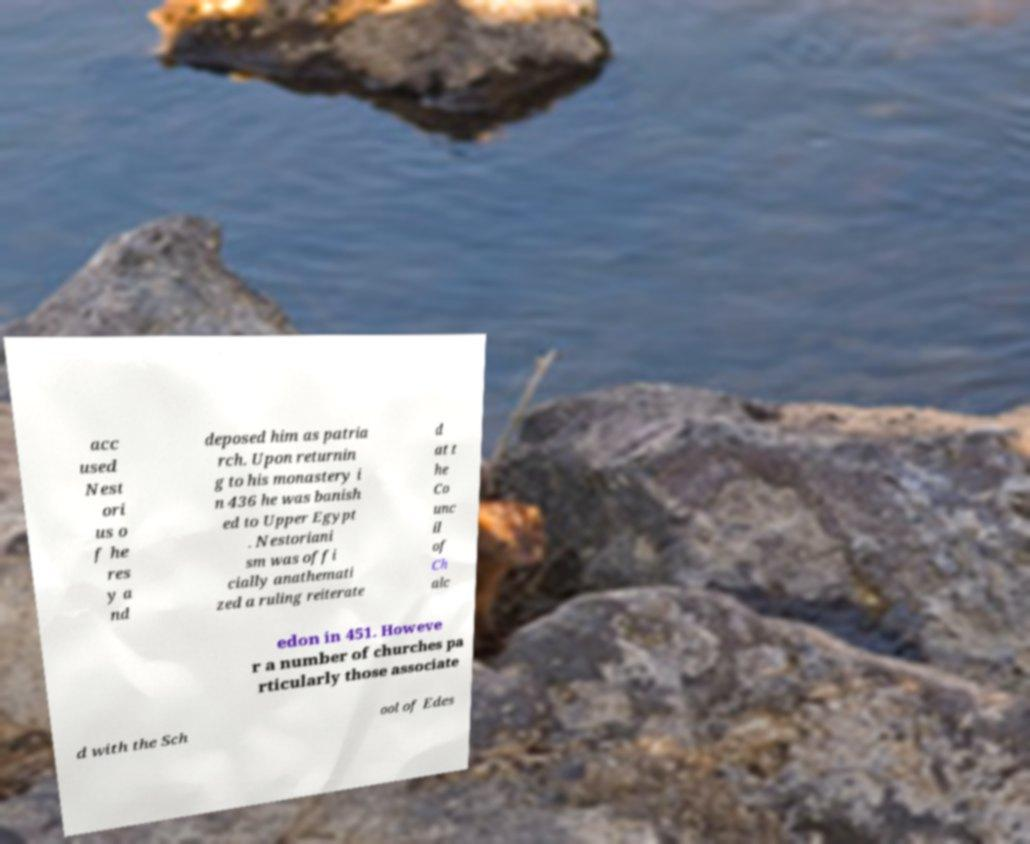Can you accurately transcribe the text from the provided image for me? acc used Nest ori us o f he res y a nd deposed him as patria rch. Upon returnin g to his monastery i n 436 he was banish ed to Upper Egypt . Nestoriani sm was offi cially anathemati zed a ruling reiterate d at t he Co unc il of Ch alc edon in 451. Howeve r a number of churches pa rticularly those associate d with the Sch ool of Edes 